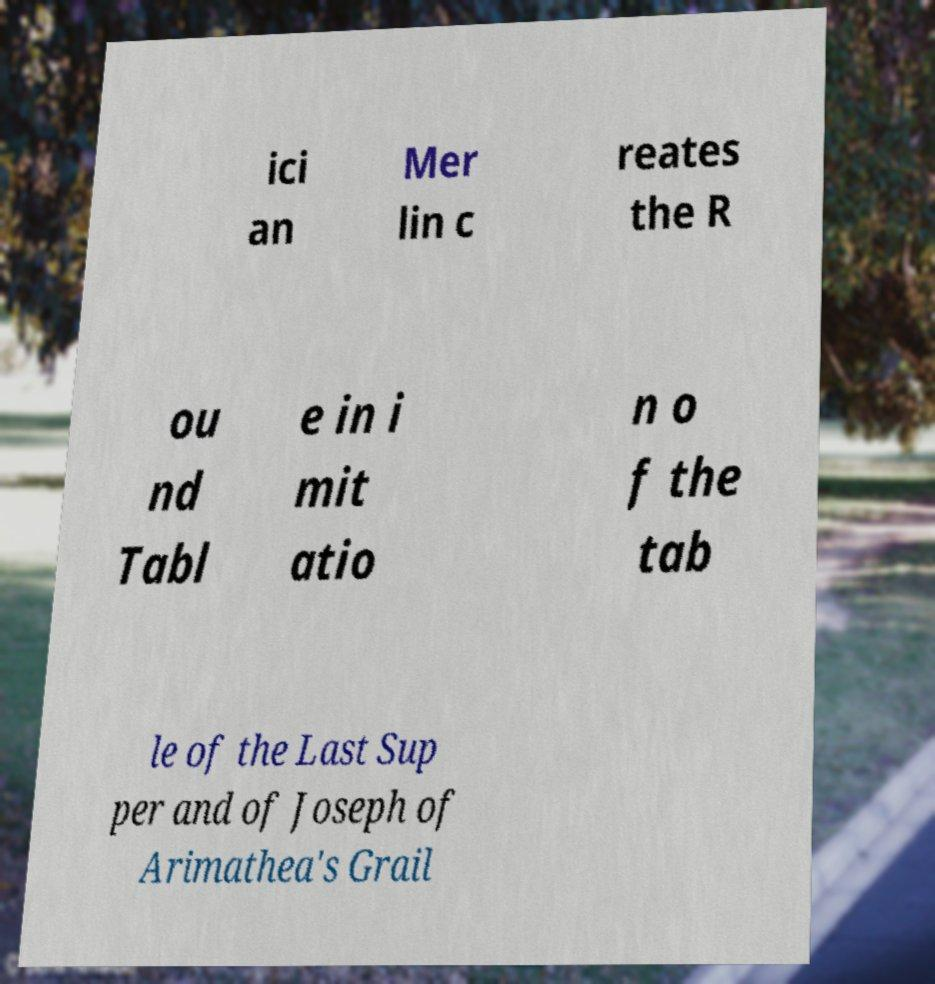Please read and relay the text visible in this image. What does it say? ici an Mer lin c reates the R ou nd Tabl e in i mit atio n o f the tab le of the Last Sup per and of Joseph of Arimathea's Grail 